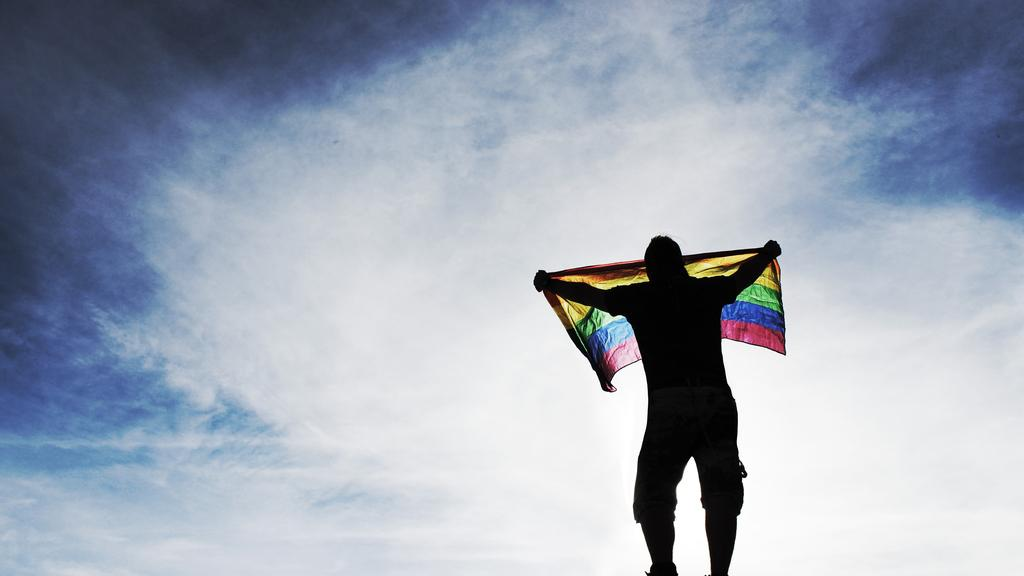What is the main subject of the image? There is a person in the image. What is the person holding in the image? The person is holding a flag. Can you describe the flag? The flag is colorful. What is the condition of the sky in the image? The sky is clear in the image. Can you see any fangs on the person holding the flag in the image? There are no fangs visible on the person holding the flag in the image. What type of bun is being used to hold the flag in place? There is no bun present in the image; the person is simply holding the flag. 